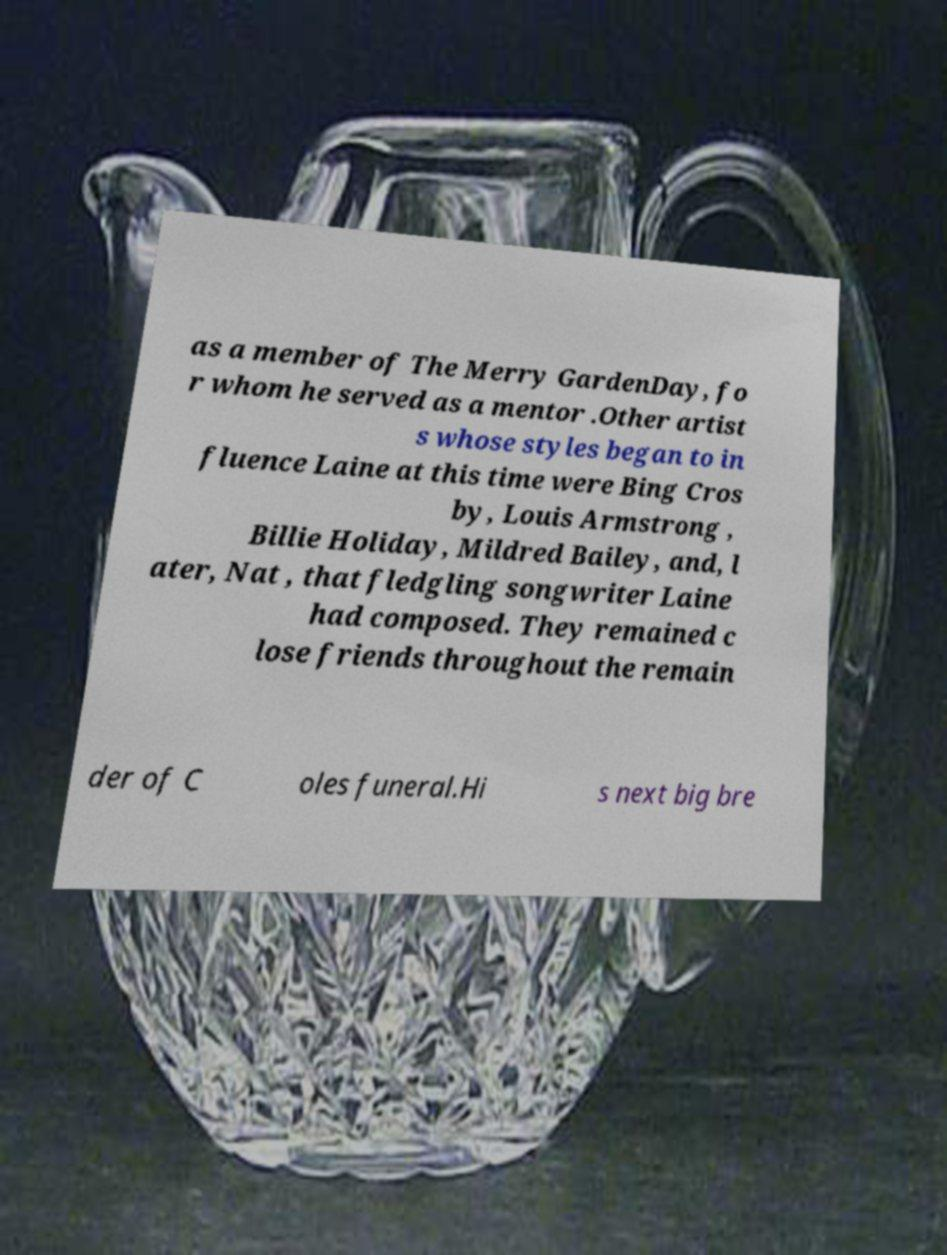For documentation purposes, I need the text within this image transcribed. Could you provide that? as a member of The Merry GardenDay, fo r whom he served as a mentor .Other artist s whose styles began to in fluence Laine at this time were Bing Cros by, Louis Armstrong , Billie Holiday, Mildred Bailey, and, l ater, Nat , that fledgling songwriter Laine had composed. They remained c lose friends throughout the remain der of C oles funeral.Hi s next big bre 